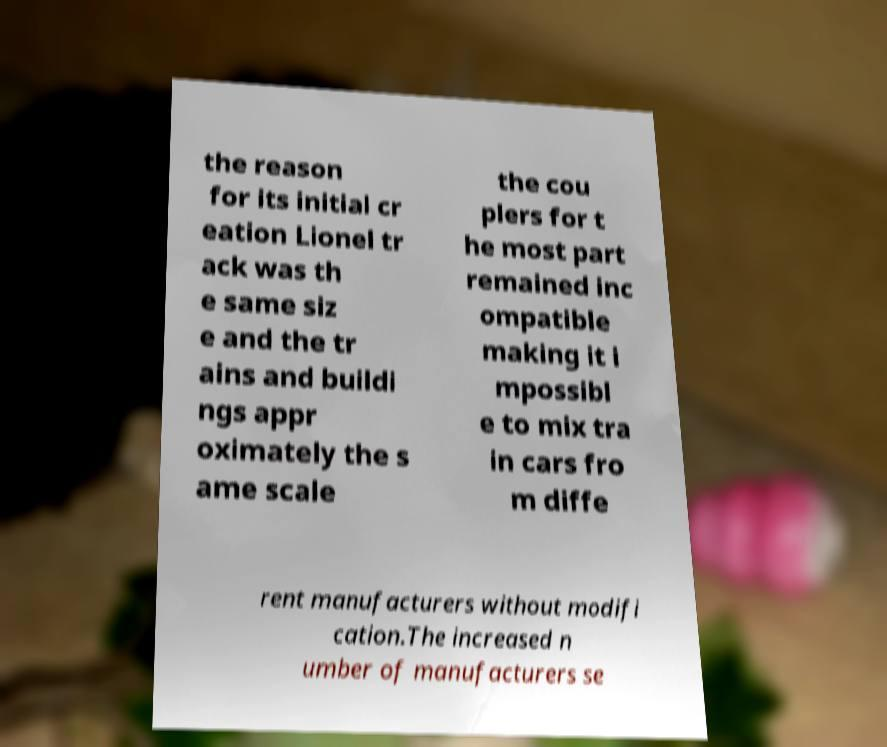For documentation purposes, I need the text within this image transcribed. Could you provide that? the reason for its initial cr eation Lionel tr ack was th e same siz e and the tr ains and buildi ngs appr oximately the s ame scale the cou plers for t he most part remained inc ompatible making it i mpossibl e to mix tra in cars fro m diffe rent manufacturers without modifi cation.The increased n umber of manufacturers se 